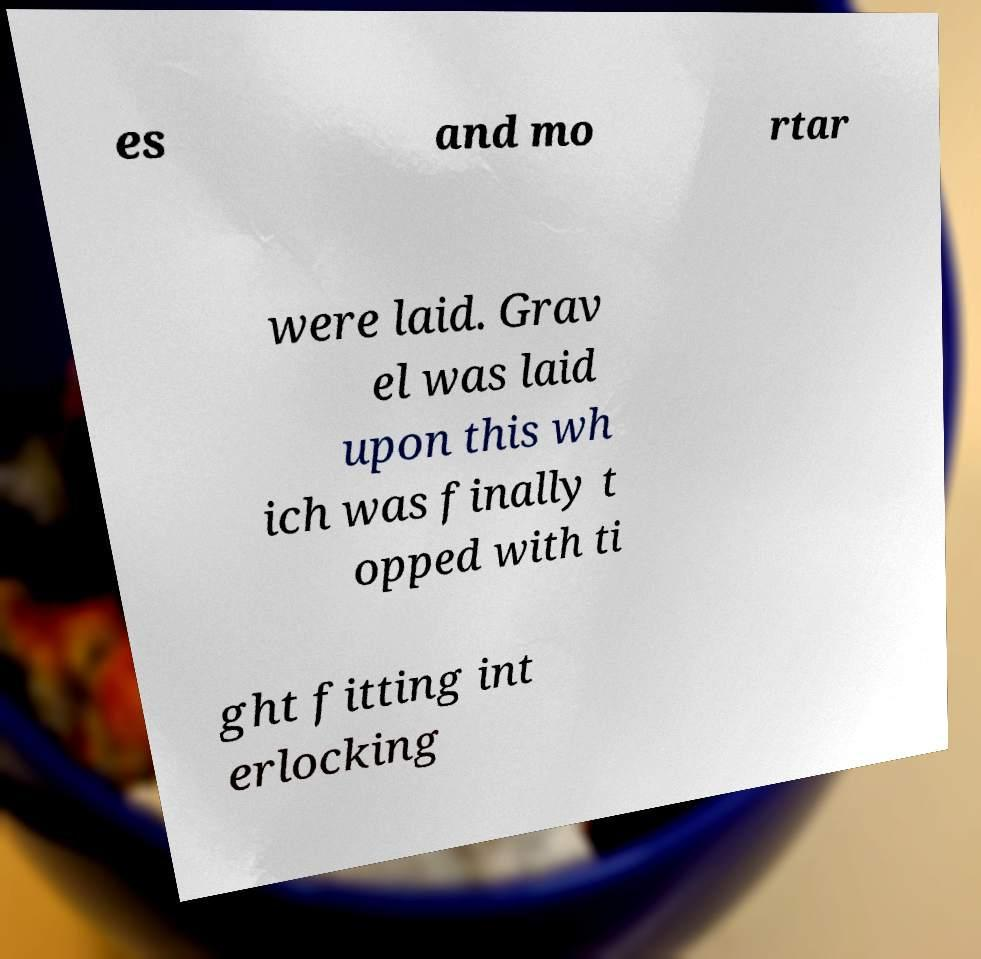Could you extract and type out the text from this image? es and mo rtar were laid. Grav el was laid upon this wh ich was finally t opped with ti ght fitting int erlocking 